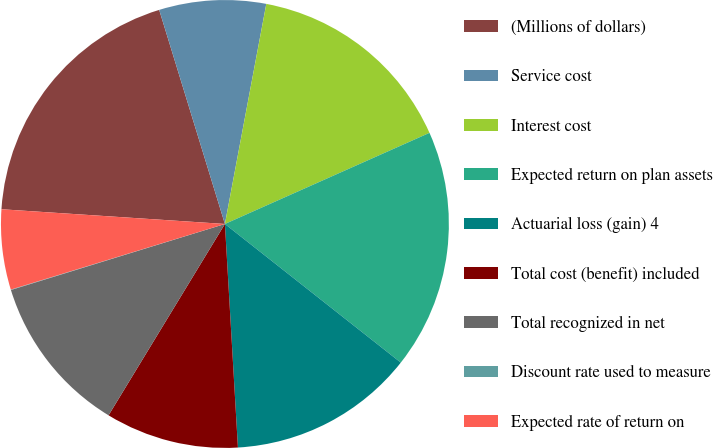Convert chart. <chart><loc_0><loc_0><loc_500><loc_500><pie_chart><fcel>(Millions of dollars)<fcel>Service cost<fcel>Interest cost<fcel>Expected return on plan assets<fcel>Actuarial loss (gain) 4<fcel>Total cost (benefit) included<fcel>Total recognized in net<fcel>Discount rate used to measure<fcel>Expected rate of return on<nl><fcel>19.21%<fcel>7.7%<fcel>15.37%<fcel>17.29%<fcel>13.45%<fcel>9.62%<fcel>11.54%<fcel>0.03%<fcel>5.78%<nl></chart> 